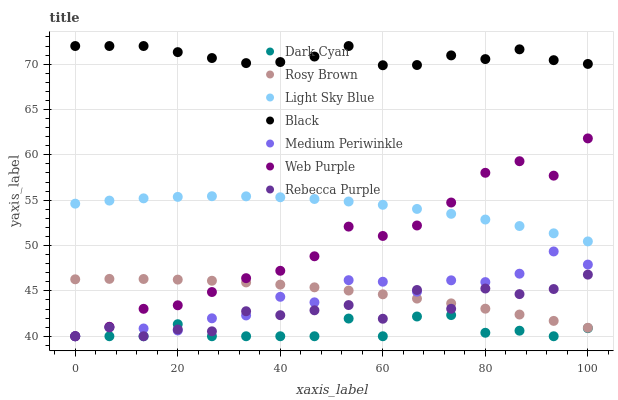Does Dark Cyan have the minimum area under the curve?
Answer yes or no. Yes. Does Black have the maximum area under the curve?
Answer yes or no. Yes. Does Medium Periwinkle have the minimum area under the curve?
Answer yes or no. No. Does Medium Periwinkle have the maximum area under the curve?
Answer yes or no. No. Is Rosy Brown the smoothest?
Answer yes or no. Yes. Is Rebecca Purple the roughest?
Answer yes or no. Yes. Is Medium Periwinkle the smoothest?
Answer yes or no. No. Is Medium Periwinkle the roughest?
Answer yes or no. No. Does Medium Periwinkle have the lowest value?
Answer yes or no. Yes. Does Light Sky Blue have the lowest value?
Answer yes or no. No. Does Black have the highest value?
Answer yes or no. Yes. Does Medium Periwinkle have the highest value?
Answer yes or no. No. Is Medium Periwinkle less than Light Sky Blue?
Answer yes or no. Yes. Is Black greater than Medium Periwinkle?
Answer yes or no. Yes. Does Rebecca Purple intersect Rosy Brown?
Answer yes or no. Yes. Is Rebecca Purple less than Rosy Brown?
Answer yes or no. No. Is Rebecca Purple greater than Rosy Brown?
Answer yes or no. No. Does Medium Periwinkle intersect Light Sky Blue?
Answer yes or no. No. 